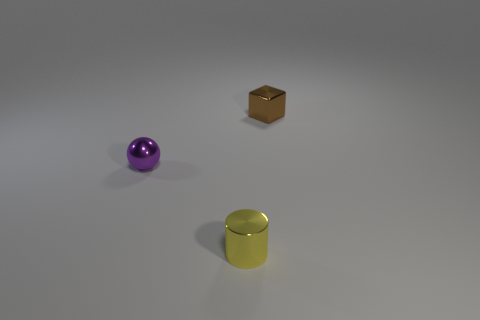What is the tiny object that is both in front of the small brown shiny block and to the right of the small purple shiny sphere made of?
Ensure brevity in your answer.  Metal. What is the color of the cylinder that is the same size as the purple thing?
Give a very brief answer. Yellow. How many big brown balls have the same material as the yellow thing?
Offer a terse response. 0. How many tiny metal objects have the same color as the shiny sphere?
Your answer should be compact. 0. What number of things are tiny things left of the yellow cylinder or things that are behind the small shiny sphere?
Make the answer very short. 2. Are there fewer tiny objects on the right side of the shiny block than small metal things?
Ensure brevity in your answer.  Yes. Are there any objects that have the same size as the yellow cylinder?
Keep it short and to the point. Yes. The block is what color?
Your response must be concise. Brown. Do the yellow metal thing and the purple metal sphere have the same size?
Make the answer very short. Yes. How many objects are either purple rubber cylinders or brown cubes?
Your answer should be very brief. 1. 